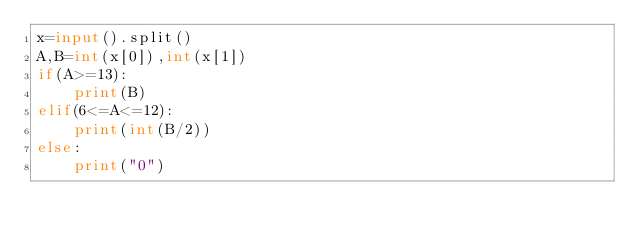Convert code to text. <code><loc_0><loc_0><loc_500><loc_500><_Python_>x=input().split()
A,B=int(x[0]),int(x[1])
if(A>=13):
    print(B)
elif(6<=A<=12):
    print(int(B/2))
else:
    print("0")
</code> 